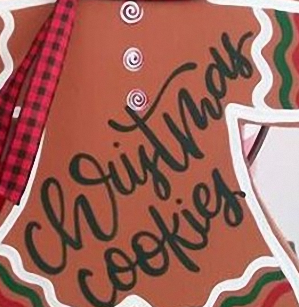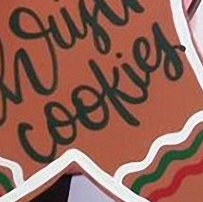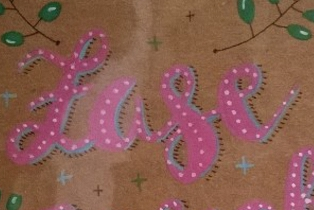Identify the words shown in these images in order, separated by a semicolon. christmas; cookies; Lase 